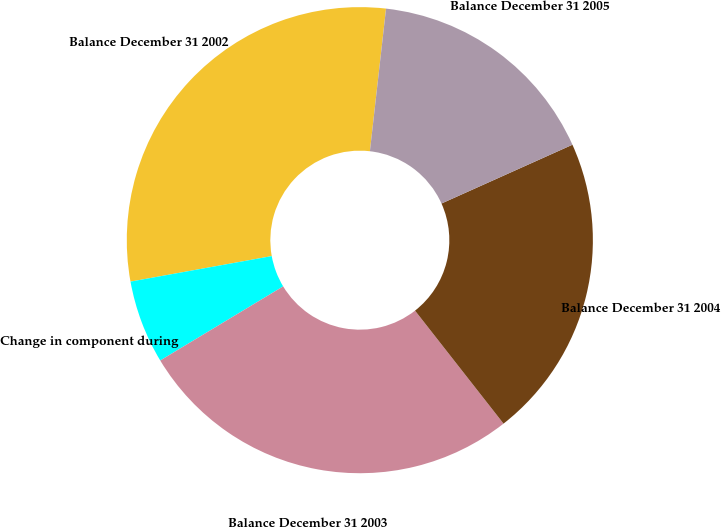<chart> <loc_0><loc_0><loc_500><loc_500><pie_chart><fcel>Balance December 31 2002<fcel>Change in component during<fcel>Balance December 31 2003<fcel>Balance December 31 2004<fcel>Balance December 31 2005<nl><fcel>29.64%<fcel>5.79%<fcel>26.94%<fcel>21.14%<fcel>16.49%<nl></chart> 